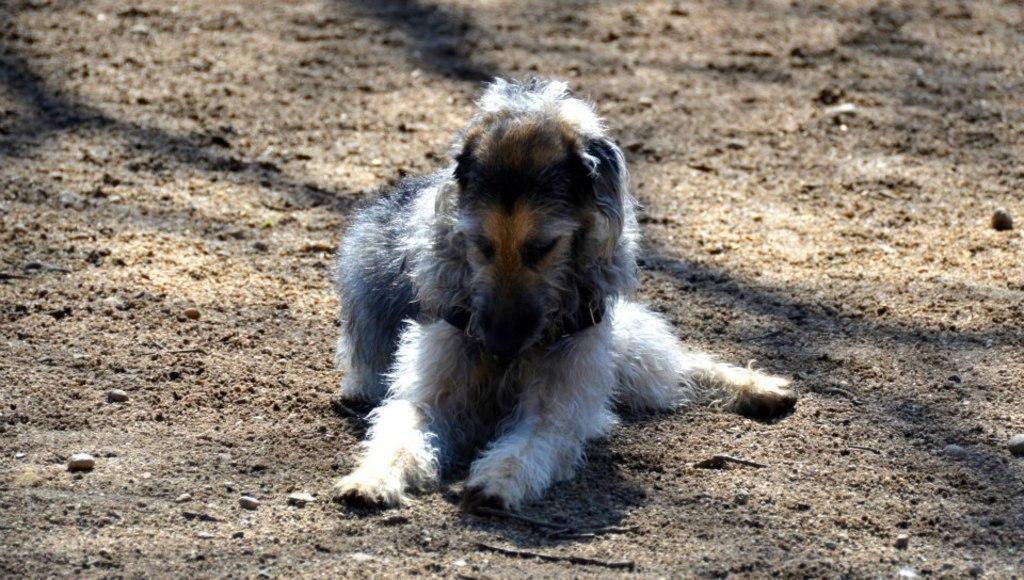Describe this image in one or two sentences. Here we can see a dog sitting on the ground. 